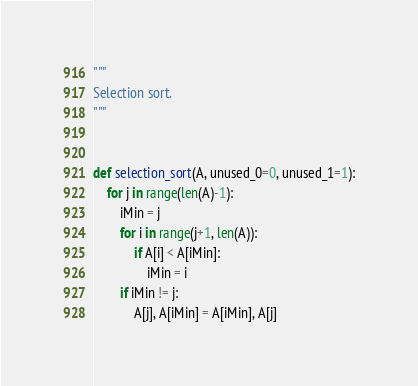Convert code to text. <code><loc_0><loc_0><loc_500><loc_500><_Python_>"""
Selection sort.
"""


def selection_sort(A, unused_0=0, unused_1=1):
    for j in range(len(A)-1):
        iMin = j
        for i in range(j+1, len(A)):
            if A[i] < A[iMin]:
                iMin = i
        if iMin != j:
            A[j], A[iMin] = A[iMin], A[j]
</code> 